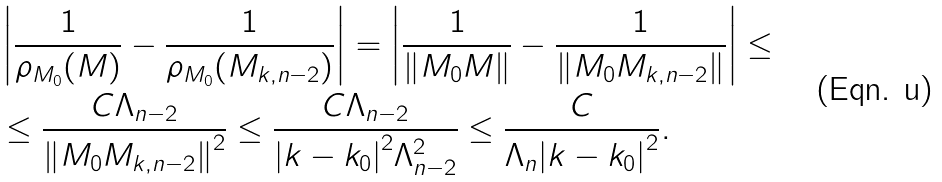Convert formula to latex. <formula><loc_0><loc_0><loc_500><loc_500>& \left | \frac { 1 } { \rho _ { M _ { 0 } } ( M ) } - \frac { 1 } { \rho _ { M _ { 0 } } ( M _ { k , n - 2 } ) } \right | = \left | \frac { 1 } { \| M _ { 0 } M \| } - \frac { 1 } { \| M _ { 0 } M _ { k , n - 2 } \| } \right | \leq \\ & \leq \frac { C \Lambda _ { n - 2 } } { { \| M _ { 0 } M _ { k , n - 2 } \| } ^ { 2 } } \leq \frac { C \Lambda _ { n - 2 } } { { | k - k _ { 0 } | } ^ { 2 } \Lambda ^ { 2 } _ { n - 2 } } \leq \frac { C } { \Lambda _ { n } { | k - k _ { 0 } | } ^ { 2 } } .</formula> 